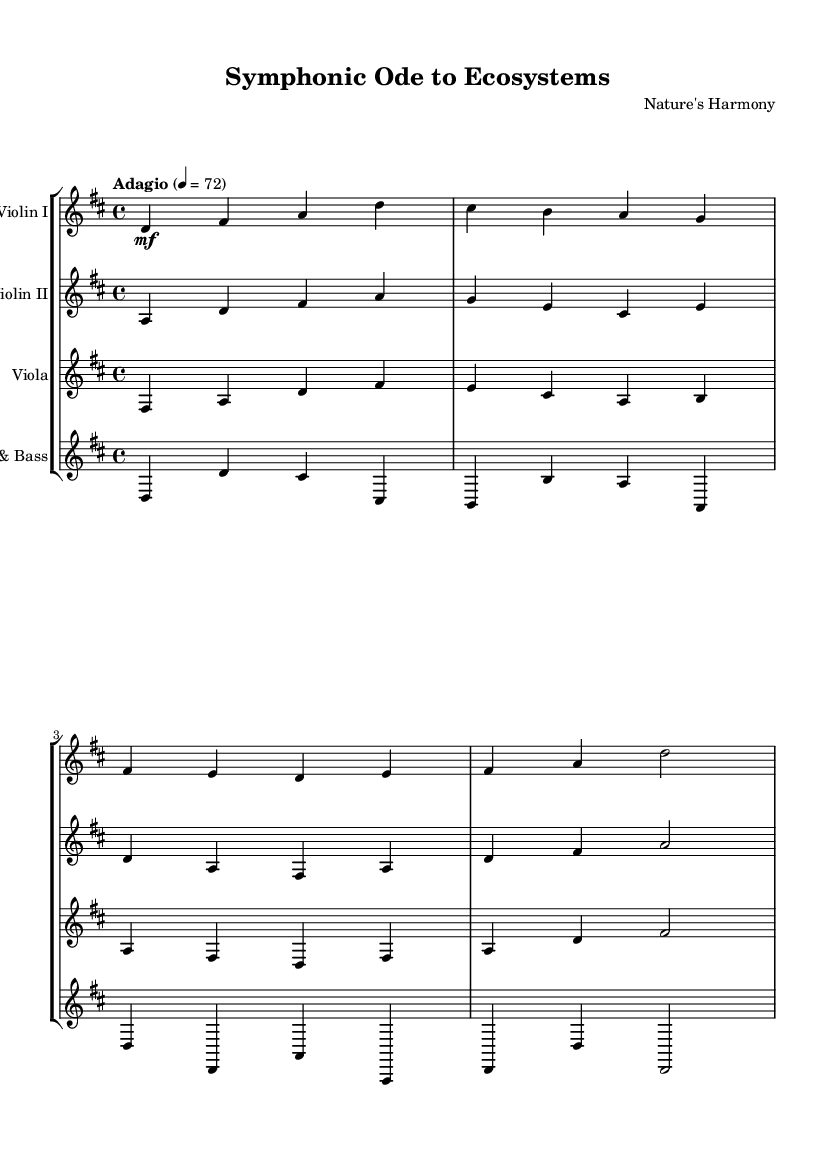What is the key signature of this music? The key signature indicates D major, which features two sharps, F# and C#. This can be determined by looking for the sharps at the beginning of the staff, which defines the tonal center of the piece.
Answer: D major What is the time signature of this music? The time signature shown in the initial part of the music, displayed as a fraction, is 4/4. This indicates there are four beats per measure, and the quarter note receives one beat.
Answer: 4/4 What is the tempo marking for this piece? The tempo marking indicated in the music states "Adagio," and specifies a beats per minute speed of 72. Adagio is a term that generally means a slow tempo, which informs the performer about the pace of the piece.
Answer: Adagio How many instruments are featured in this score? The score contains four distinct staves, indicating four instruments: Violin I, Violin II, Viola, and Cello & Bass. By counting the staves, we can determine the number of instruments involved in the performance.
Answer: Four Which instrument plays the highest pitch in this score? The Violin I part typically plays the highest pitch range compared to the other instruments provided in the score, as violins are designed to play higher notes than the viola or cello. This can be assessed by visually examining the notated pitches across the staves.
Answer: Violin I What dynamic marking is indicated for Violin I at the start? The dynamic marking for Violin I at the beginning is mezzo-forte, denoted by 'mf' in the score. This marking indicates that the performer should play moderately loud, influencing how the music is interpreted.
Answer: Mezzo-forte 